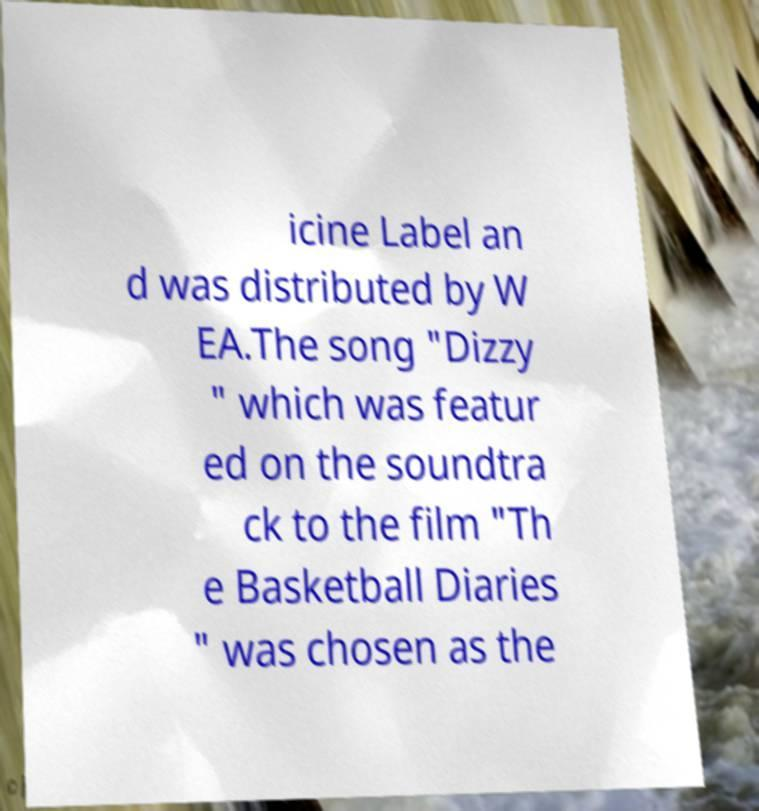For documentation purposes, I need the text within this image transcribed. Could you provide that? icine Label an d was distributed by W EA.The song "Dizzy " which was featur ed on the soundtra ck to the film "Th e Basketball Diaries " was chosen as the 